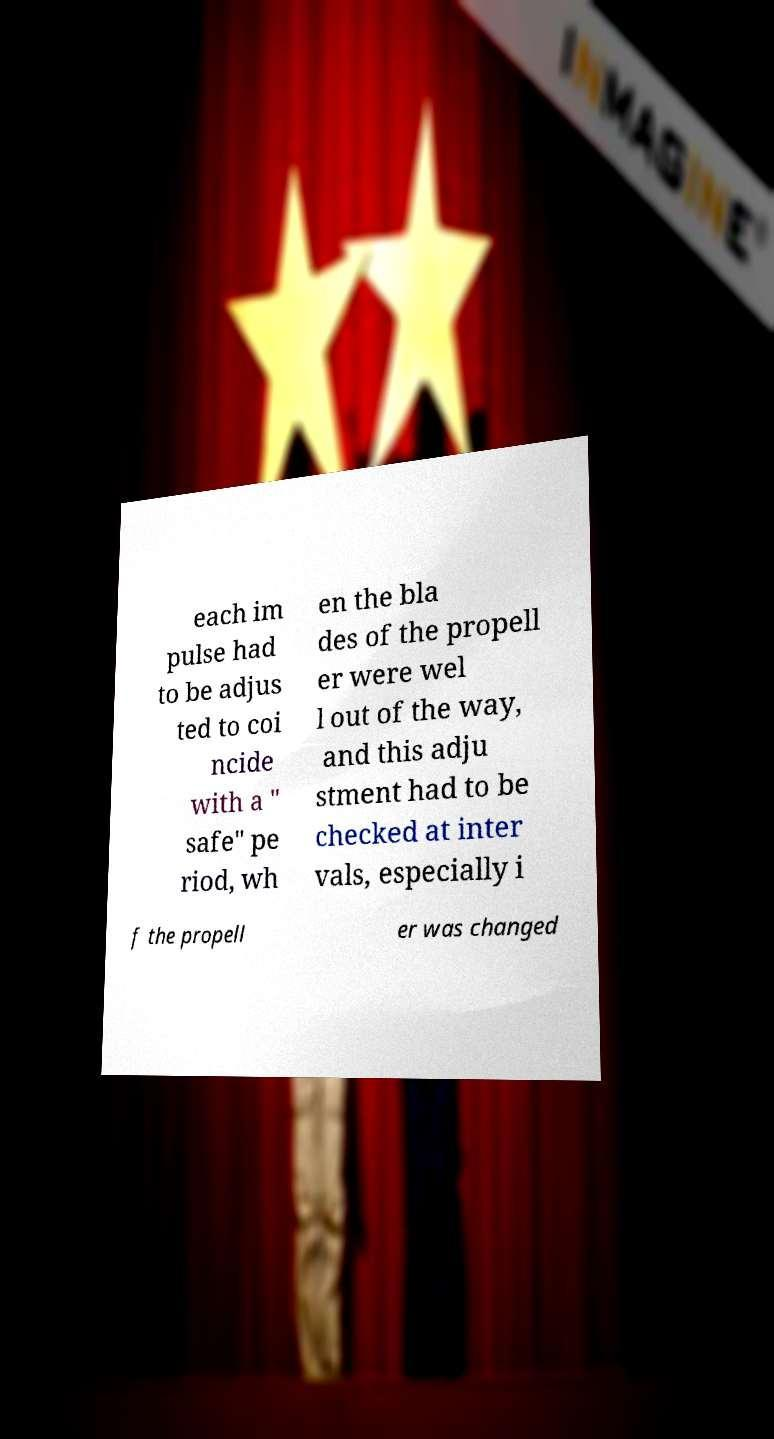Please identify and transcribe the text found in this image. each im pulse had to be adjus ted to coi ncide with a " safe" pe riod, wh en the bla des of the propell er were wel l out of the way, and this adju stment had to be checked at inter vals, especially i f the propell er was changed 